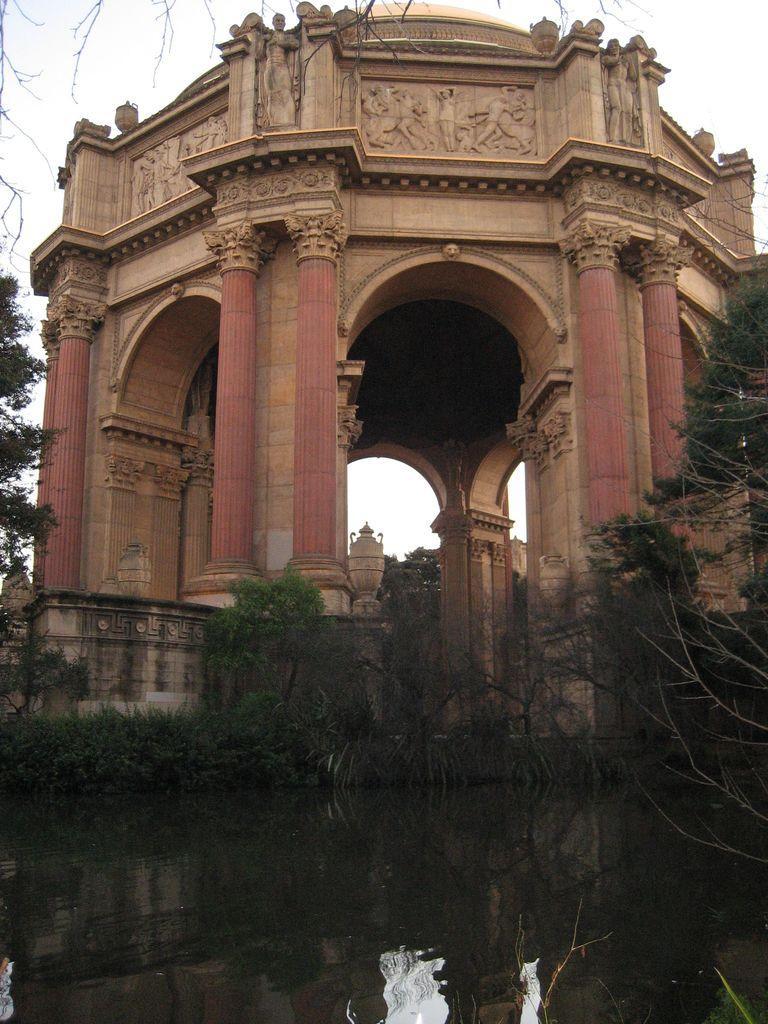Could you give a brief overview of what you see in this image? In the foreground we can see the water. Here we can see the trees on the left side and the right side as well. Here we can see the palace of fine arts. Here we can see the arch design construction. Here we can see the statues on the top. 